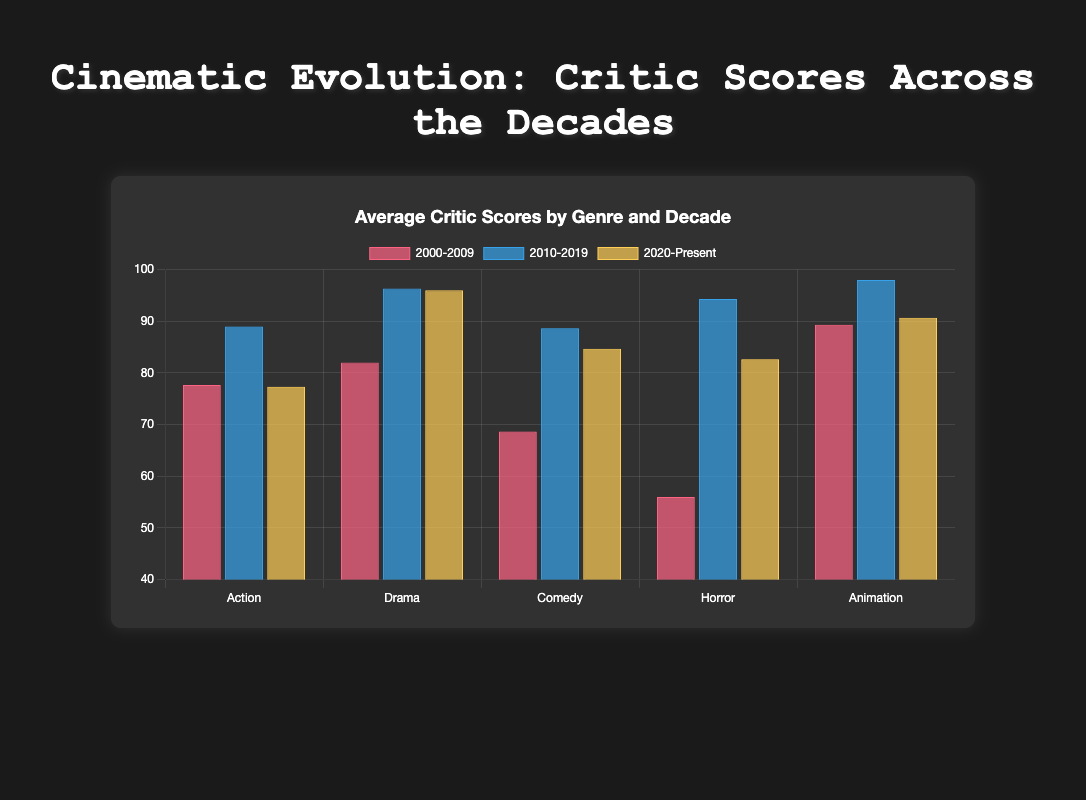Which genre had the highest average critic score in the 2010-2019 decade? Look for the tallest bar under the "2010-2019" group and identify its genre. According to the chart, the highest average critic score bar corresponds to the Animation genre.
Answer: Animation How does the average critic score for Horror films in 2000-2009 compare to 2020-Present? Identify the height of the bars representing Horror for both 2000-2009 and 2020-Present. The 2000-2009 bar is shorter than the 2020-Present bar, indicating a lower average score in the earlier decade.
Answer: Lower in 2000-2009 Which decade had the lowest average critic score for Action films? Compare the heights of all bars representing Action films across the decades. The shortest bar is in the "2020-Present" group.
Answer: 2020-Present What's the difference in the average critic scores for Comedy between 2000-2009 and 2010-2019? Subtract the height of the "2000-2009" bar for Comedy from the height of the "2010-2019" bar for Comedy.
Answer: 24 (76 - 66 + 64) Which decade shows the most improvement in average critic scores for Animation films compared to the previous decade? Compare the height differences between consecutive decades for Animation. The largest increase is from 2000-2009 to 2010-2019.
Answer: 2010-2019 What's the combined average critic score for Drama films across all decades? Sum the average scores for Drama in each decade and then divide by the number of decades (74 + 96 + 94) / 3.
Answer: 88 In which genre did all decades consistently maintain high critic scores? Verify that the bars for all decades within the genre are high across the chart. Animation consistently shows very high bars across all decades.
Answer: Animation Which genre had the smallest variation in average critic scores across the three decades? Observe the differences in bar heights for each genre across all three decades. The genre with the least variation in bar height is Action.
Answer: Action 